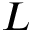Convert formula to latex. <formula><loc_0><loc_0><loc_500><loc_500>L</formula> 